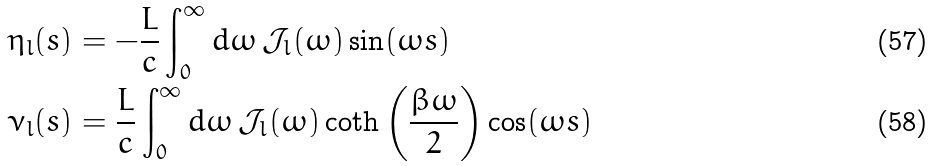Convert formula to latex. <formula><loc_0><loc_0><loc_500><loc_500>\eta _ { l } ( s ) & = - \frac { L } { c } \int _ { 0 } ^ { \infty } d \omega \, \mathcal { J } _ { l } ( \omega ) \sin ( \omega s ) \\ \nu _ { l } ( s ) & = \frac { L } { c } \int _ { 0 } ^ { \infty } d \omega \, \mathcal { J } _ { l } ( \omega ) \coth { \left ( \frac { \beta \omega } { 2 } \right ) } \cos ( \omega s )</formula> 